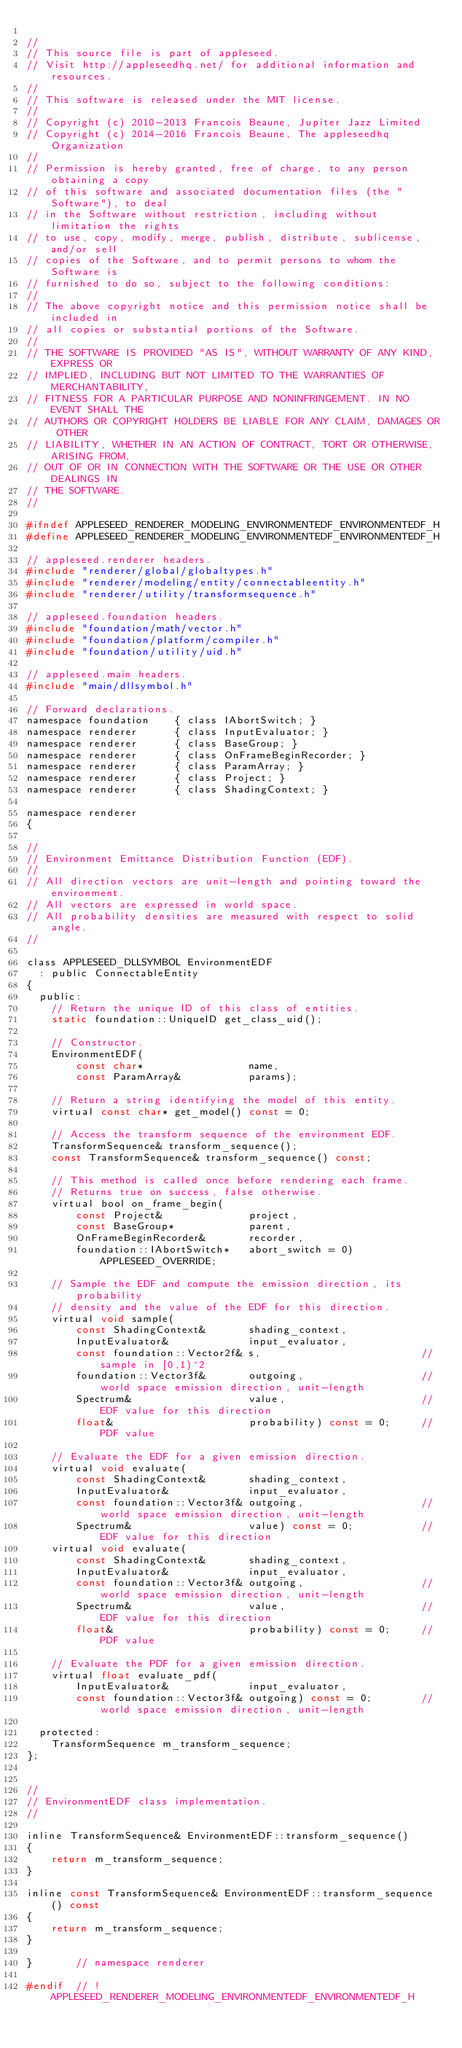Convert code to text. <code><loc_0><loc_0><loc_500><loc_500><_C_>
//
// This source file is part of appleseed.
// Visit http://appleseedhq.net/ for additional information and resources.
//
// This software is released under the MIT license.
//
// Copyright (c) 2010-2013 Francois Beaune, Jupiter Jazz Limited
// Copyright (c) 2014-2016 Francois Beaune, The appleseedhq Organization
//
// Permission is hereby granted, free of charge, to any person obtaining a copy
// of this software and associated documentation files (the "Software"), to deal
// in the Software without restriction, including without limitation the rights
// to use, copy, modify, merge, publish, distribute, sublicense, and/or sell
// copies of the Software, and to permit persons to whom the Software is
// furnished to do so, subject to the following conditions:
//
// The above copyright notice and this permission notice shall be included in
// all copies or substantial portions of the Software.
//
// THE SOFTWARE IS PROVIDED "AS IS", WITHOUT WARRANTY OF ANY KIND, EXPRESS OR
// IMPLIED, INCLUDING BUT NOT LIMITED TO THE WARRANTIES OF MERCHANTABILITY,
// FITNESS FOR A PARTICULAR PURPOSE AND NONINFRINGEMENT. IN NO EVENT SHALL THE
// AUTHORS OR COPYRIGHT HOLDERS BE LIABLE FOR ANY CLAIM, DAMAGES OR OTHER
// LIABILITY, WHETHER IN AN ACTION OF CONTRACT, TORT OR OTHERWISE, ARISING FROM,
// OUT OF OR IN CONNECTION WITH THE SOFTWARE OR THE USE OR OTHER DEALINGS IN
// THE SOFTWARE.
//

#ifndef APPLESEED_RENDERER_MODELING_ENVIRONMENTEDF_ENVIRONMENTEDF_H
#define APPLESEED_RENDERER_MODELING_ENVIRONMENTEDF_ENVIRONMENTEDF_H

// appleseed.renderer headers.
#include "renderer/global/globaltypes.h"
#include "renderer/modeling/entity/connectableentity.h"
#include "renderer/utility/transformsequence.h"

// appleseed.foundation headers.
#include "foundation/math/vector.h"
#include "foundation/platform/compiler.h"
#include "foundation/utility/uid.h"

// appleseed.main headers.
#include "main/dllsymbol.h"

// Forward declarations.
namespace foundation    { class IAbortSwitch; }
namespace renderer      { class InputEvaluator; }
namespace renderer      { class BaseGroup; }
namespace renderer      { class OnFrameBeginRecorder; }
namespace renderer      { class ParamArray; }
namespace renderer      { class Project; }
namespace renderer      { class ShadingContext; }

namespace renderer
{

//
// Environment Emittance Distribution Function (EDF).
//
// All direction vectors are unit-length and pointing toward the environment.
// All vectors are expressed in world space.
// All probability densities are measured with respect to solid angle.
//

class APPLESEED_DLLSYMBOL EnvironmentEDF
  : public ConnectableEntity
{
  public:
    // Return the unique ID of this class of entities.
    static foundation::UniqueID get_class_uid();

    // Constructor.
    EnvironmentEDF(
        const char*                 name,
        const ParamArray&           params);

    // Return a string identifying the model of this entity.
    virtual const char* get_model() const = 0;

    // Access the transform sequence of the environment EDF.
    TransformSequence& transform_sequence();
    const TransformSequence& transform_sequence() const;

    // This method is called once before rendering each frame.
    // Returns true on success, false otherwise.
    virtual bool on_frame_begin(
        const Project&              project,
        const BaseGroup*            parent,
        OnFrameBeginRecorder&       recorder,
        foundation::IAbortSwitch*   abort_switch = 0) APPLESEED_OVERRIDE;

    // Sample the EDF and compute the emission direction, its probability
    // density and the value of the EDF for this direction.
    virtual void sample(
        const ShadingContext&       shading_context,
        InputEvaluator&             input_evaluator,
        const foundation::Vector2f& s,                          // sample in [0,1)^2
        foundation::Vector3f&       outgoing,                   // world space emission direction, unit-length
        Spectrum&                   value,                      // EDF value for this direction
        float&                      probability) const = 0;     // PDF value

    // Evaluate the EDF for a given emission direction.
    virtual void evaluate(
        const ShadingContext&       shading_context,
        InputEvaluator&             input_evaluator,
        const foundation::Vector3f& outgoing,                   // world space emission direction, unit-length
        Spectrum&                   value) const = 0;           // EDF value for this direction
    virtual void evaluate(
        const ShadingContext&       shading_context,
        InputEvaluator&             input_evaluator,
        const foundation::Vector3f& outgoing,                   // world space emission direction, unit-length
        Spectrum&                   value,                      // EDF value for this direction
        float&                      probability) const = 0;     // PDF value

    // Evaluate the PDF for a given emission direction.
    virtual float evaluate_pdf(
        InputEvaluator&             input_evaluator,
        const foundation::Vector3f& outgoing) const = 0;        // world space emission direction, unit-length

  protected:
    TransformSequence m_transform_sequence;
};


//
// EnvironmentEDF class implementation.
//

inline TransformSequence& EnvironmentEDF::transform_sequence()
{
    return m_transform_sequence;
}

inline const TransformSequence& EnvironmentEDF::transform_sequence() const
{
    return m_transform_sequence;
}

}       // namespace renderer

#endif  // !APPLESEED_RENDERER_MODELING_ENVIRONMENTEDF_ENVIRONMENTEDF_H
</code> 